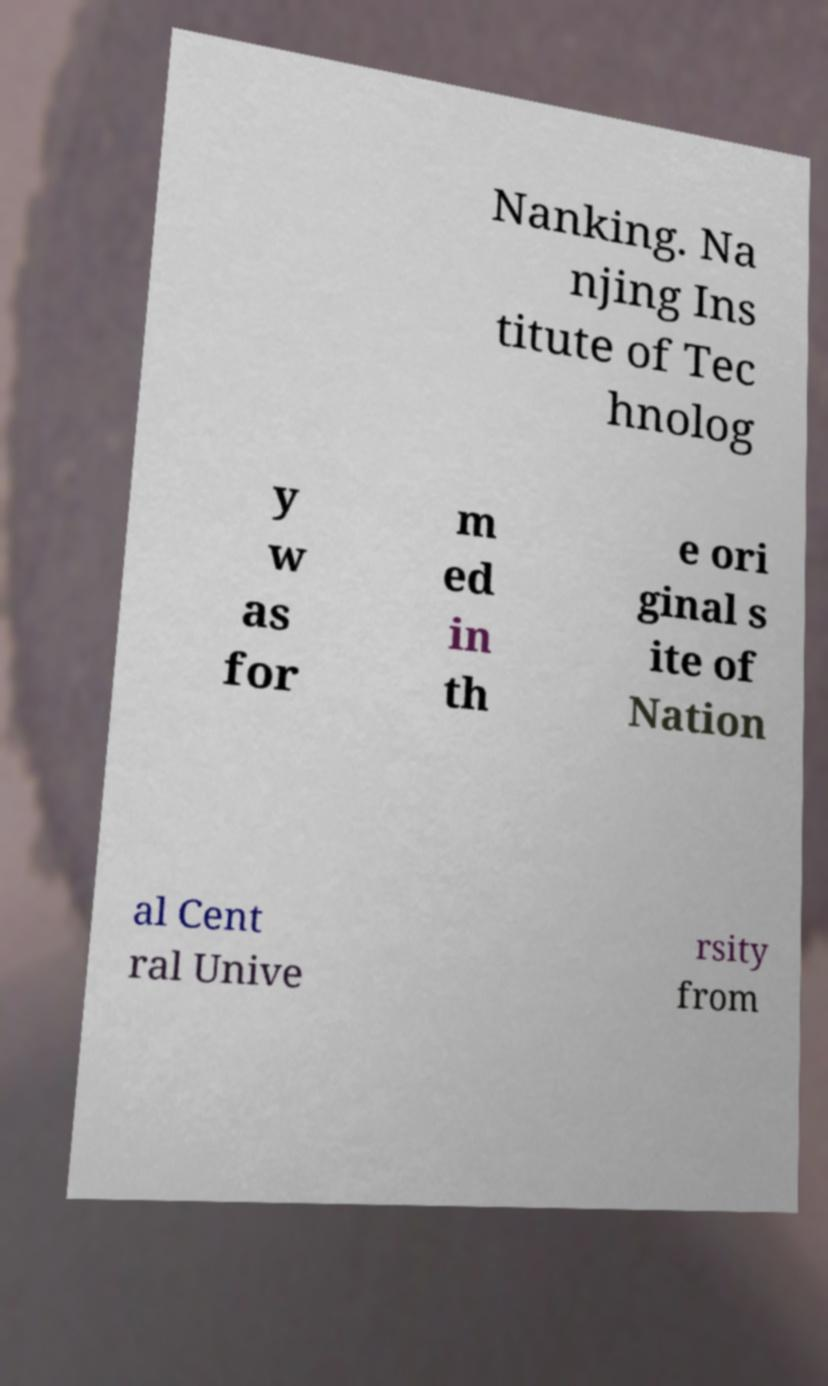Please identify and transcribe the text found in this image. Nanking. Na njing Ins titute of Tec hnolog y w as for m ed in th e ori ginal s ite of Nation al Cent ral Unive rsity from 